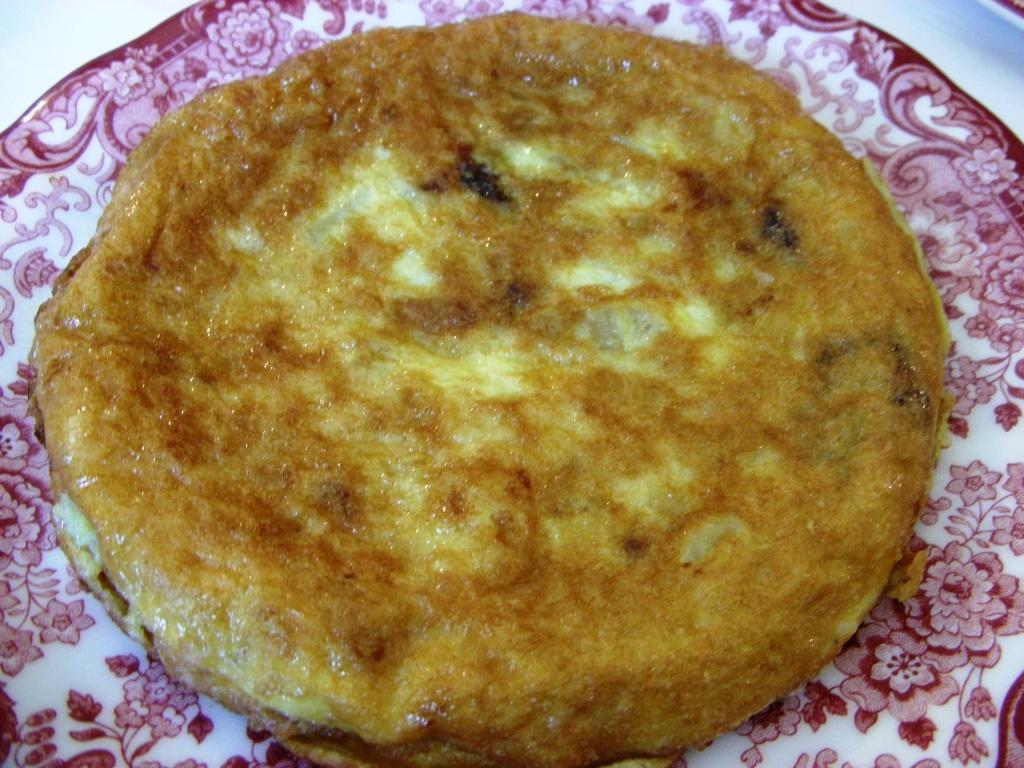What can be seen on the plate in the image? There is a food item on the plate in the image. Can you describe the plate in the image? The plate is visible in the image, but no specific details about its shape, color, or material are provided. Where is the nearest park to the plate in the image? There is no information about the location of the plate or the presence of a park in the image, so it is not possible to answer this question. 